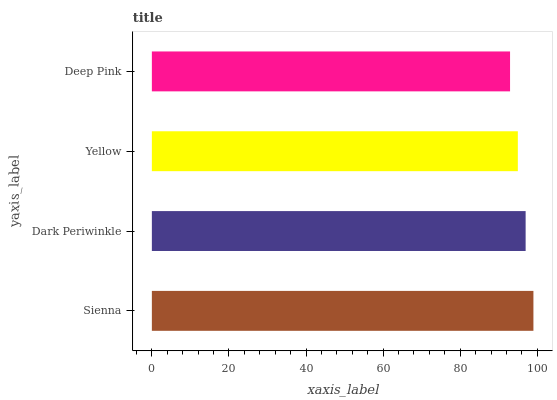Is Deep Pink the minimum?
Answer yes or no. Yes. Is Sienna the maximum?
Answer yes or no. Yes. Is Dark Periwinkle the minimum?
Answer yes or no. No. Is Dark Periwinkle the maximum?
Answer yes or no. No. Is Sienna greater than Dark Periwinkle?
Answer yes or no. Yes. Is Dark Periwinkle less than Sienna?
Answer yes or no. Yes. Is Dark Periwinkle greater than Sienna?
Answer yes or no. No. Is Sienna less than Dark Periwinkle?
Answer yes or no. No. Is Dark Periwinkle the high median?
Answer yes or no. Yes. Is Yellow the low median?
Answer yes or no. Yes. Is Sienna the high median?
Answer yes or no. No. Is Deep Pink the low median?
Answer yes or no. No. 